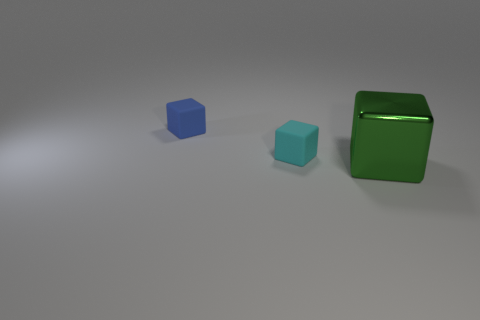Add 1 green objects. How many objects exist? 4 Add 2 big shiny cubes. How many big shiny cubes are left? 3 Add 3 large gray balls. How many large gray balls exist? 3 Subtract 0 gray cylinders. How many objects are left? 3 Subtract all big red shiny spheres. Subtract all small cyan cubes. How many objects are left? 2 